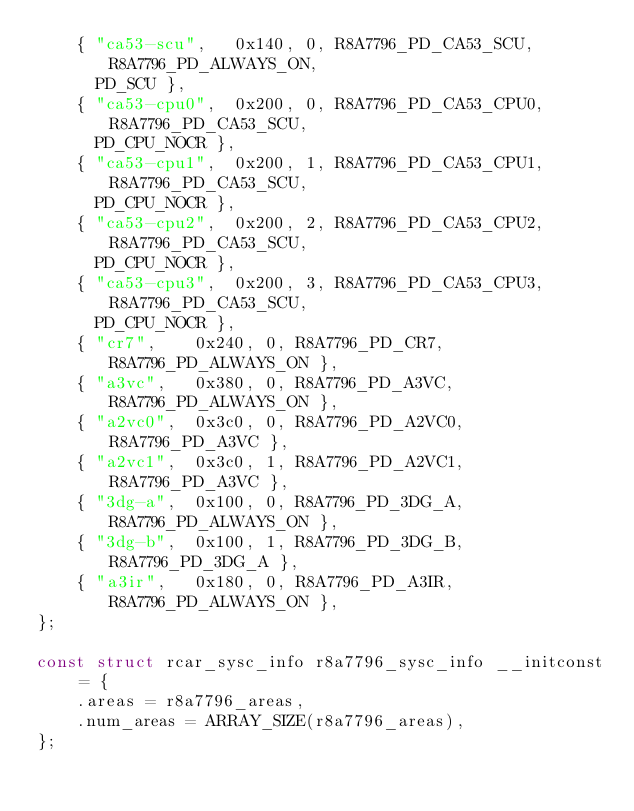<code> <loc_0><loc_0><loc_500><loc_500><_C_>	{ "ca53-scu",	0x140, 0, R8A7796_PD_CA53_SCU,	R8A7796_PD_ALWAYS_ON,
	  PD_SCU },
	{ "ca53-cpu0",	0x200, 0, R8A7796_PD_CA53_CPU0,	R8A7796_PD_CA53_SCU,
	  PD_CPU_NOCR },
	{ "ca53-cpu1",	0x200, 1, R8A7796_PD_CA53_CPU1,	R8A7796_PD_CA53_SCU,
	  PD_CPU_NOCR },
	{ "ca53-cpu2",	0x200, 2, R8A7796_PD_CA53_CPU2,	R8A7796_PD_CA53_SCU,
	  PD_CPU_NOCR },
	{ "ca53-cpu3",	0x200, 3, R8A7796_PD_CA53_CPU3,	R8A7796_PD_CA53_SCU,
	  PD_CPU_NOCR },
	{ "cr7",	0x240, 0, R8A7796_PD_CR7,	R8A7796_PD_ALWAYS_ON },
	{ "a3vc",	0x380, 0, R8A7796_PD_A3VC,	R8A7796_PD_ALWAYS_ON },
	{ "a2vc0",	0x3c0, 0, R8A7796_PD_A2VC0,	R8A7796_PD_A3VC },
	{ "a2vc1",	0x3c0, 1, R8A7796_PD_A2VC1,	R8A7796_PD_A3VC },
	{ "3dg-a",	0x100, 0, R8A7796_PD_3DG_A,	R8A7796_PD_ALWAYS_ON },
	{ "3dg-b",	0x100, 1, R8A7796_PD_3DG_B,	R8A7796_PD_3DG_A },
	{ "a3ir",	0x180, 0, R8A7796_PD_A3IR,	R8A7796_PD_ALWAYS_ON },
};

const struct rcar_sysc_info r8a7796_sysc_info __initconst = {
	.areas = r8a7796_areas,
	.num_areas = ARRAY_SIZE(r8a7796_areas),
};
</code> 